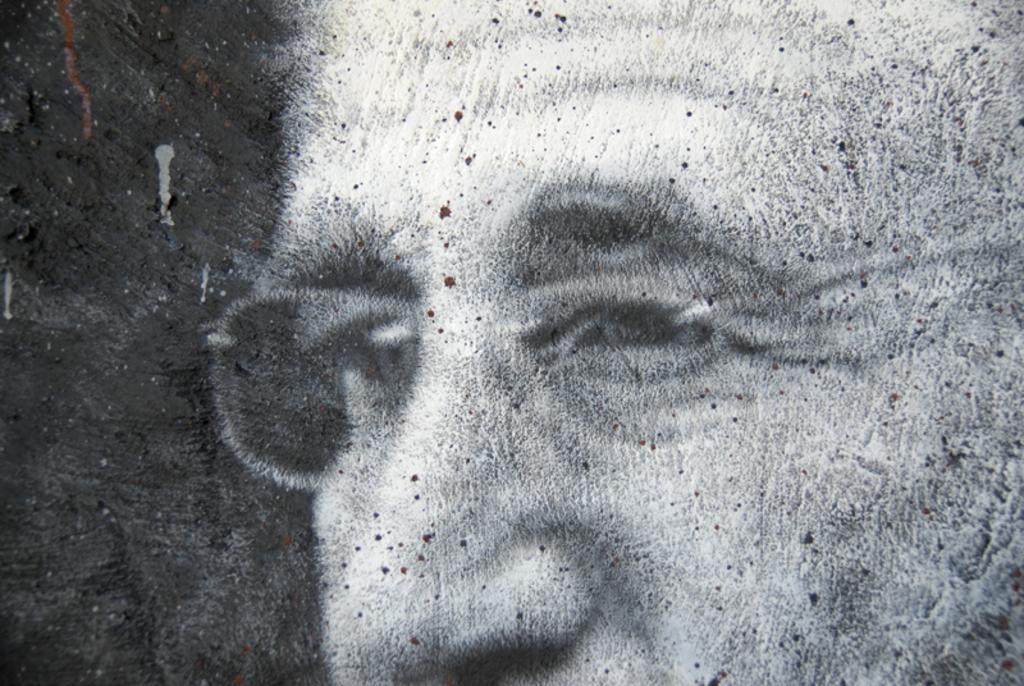Describe this image in one or two sentences. It is the blur image of a person who is wearing the spectacles. It is the black and white image. There are dots on the face. 